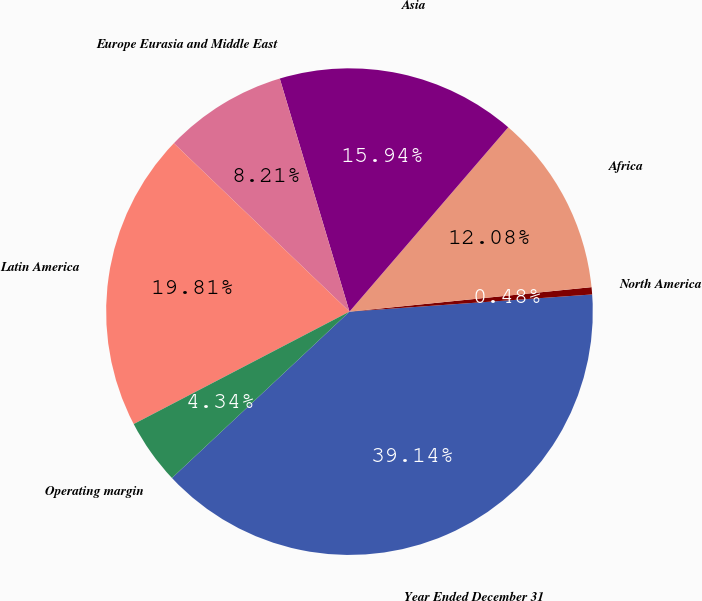<chart> <loc_0><loc_0><loc_500><loc_500><pie_chart><fcel>Year Ended December 31<fcel>North America<fcel>Africa<fcel>Asia<fcel>Europe Eurasia and Middle East<fcel>Latin America<fcel>Operating margin<nl><fcel>39.14%<fcel>0.48%<fcel>12.08%<fcel>15.94%<fcel>8.21%<fcel>19.81%<fcel>4.34%<nl></chart> 